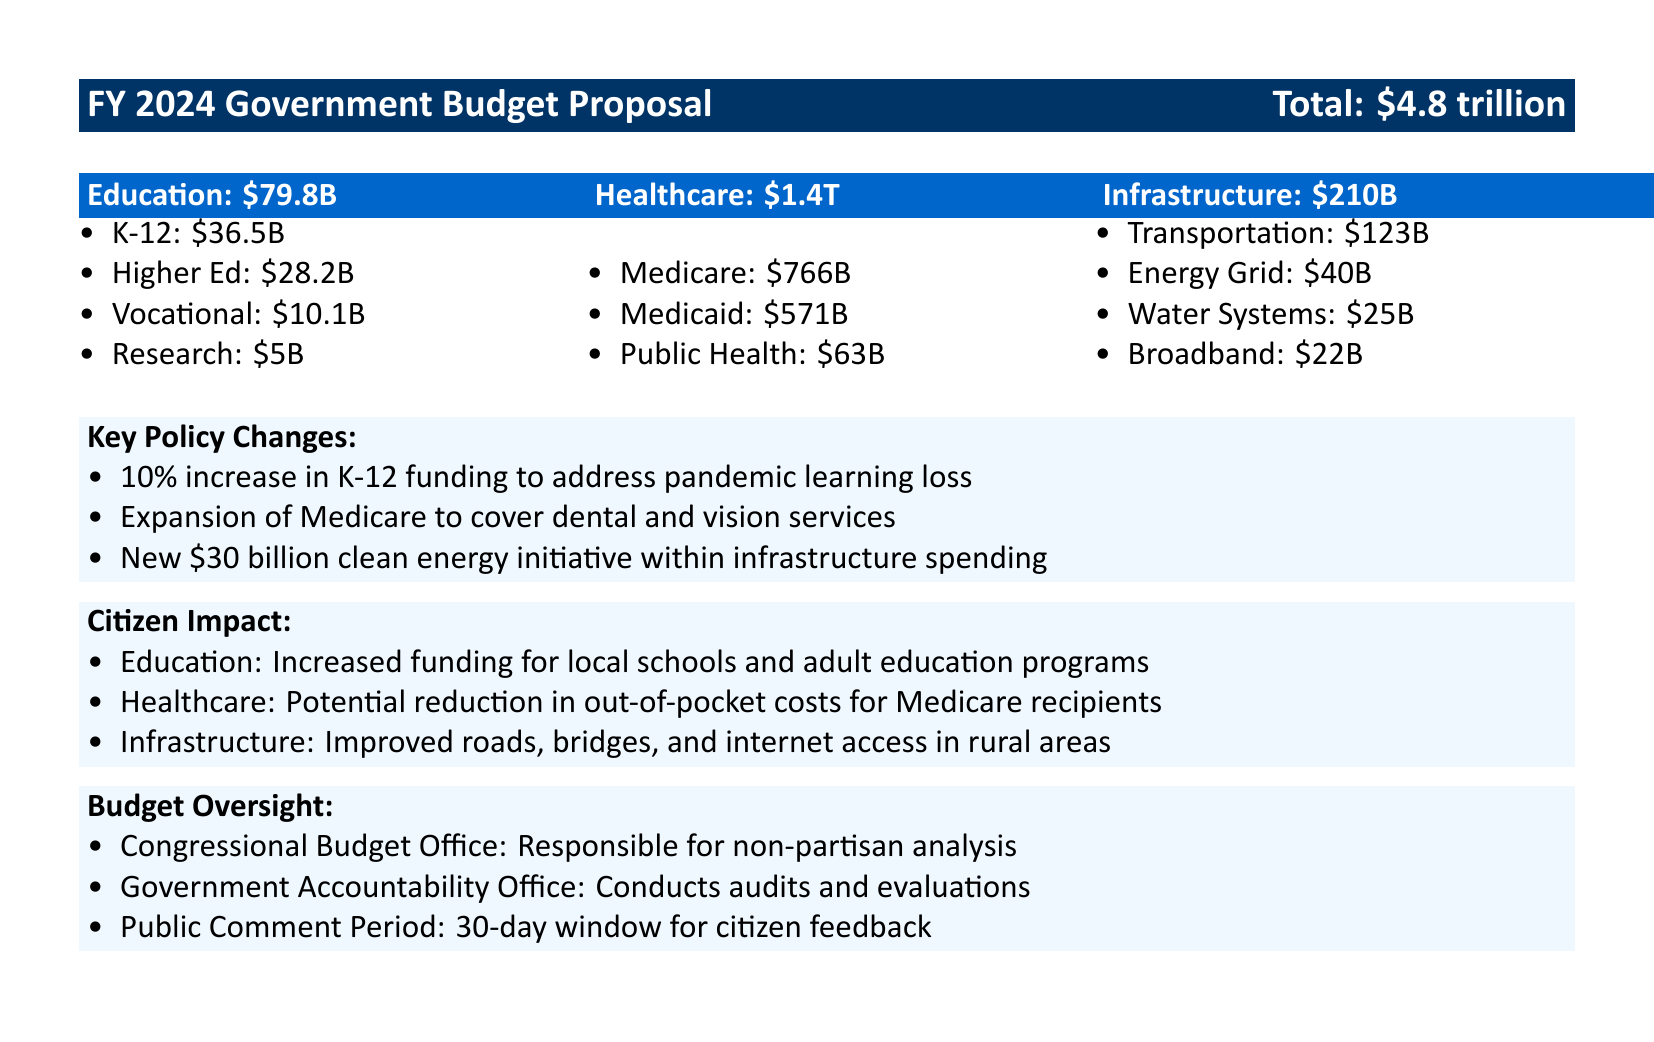What is the total amount allocated for education? The education allocation is stated explicitly in the document under the education section, which lists it as $79.8 billion.
Answer: $79.8B How much funding is designated for Medicare? The document specifies that Medicare funding is $766 billion, which is listed in the healthcare section.
Answer: $766B What percentage increase is proposed for K-12 funding? The document mentions a 10% increase in K-12 funding as a key policy change.
Answer: 10% What new initiative is included in the infrastructure spending? The document outlines a new $30 billion clean energy initiative as part of the infrastructure spending.
Answer: $30 billion clean energy initiative How much is allocated for vocational education? The vocational education funding is specifically listed in the education section of the document as $10.1 billion.
Answer: $10.1B What is the total healthcare budget? The healthcare budget total is clearly indicated in the document as $1.4 trillion.
Answer: $1.4T Who is responsible for non-partisan analysis of the budget? The document names the Congressional Budget Office as responsible for non-partisan analysis, providing insight into budget oversight.
Answer: Congressional Budget Office What type of feedback opportunity is mentioned for citizens? A public comment period is noted in the document, allowing for citizen feedback on the budget proposal.
Answer: 30-day window for citizen feedback 